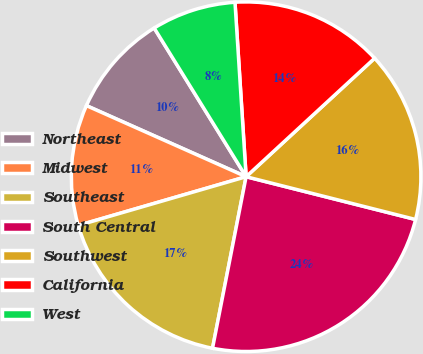<chart> <loc_0><loc_0><loc_500><loc_500><pie_chart><fcel>Northeast<fcel>Midwest<fcel>Southeast<fcel>South Central<fcel>Southwest<fcel>California<fcel>West<nl><fcel>9.52%<fcel>11.16%<fcel>17.43%<fcel>24.14%<fcel>15.79%<fcel>14.16%<fcel>7.8%<nl></chart> 